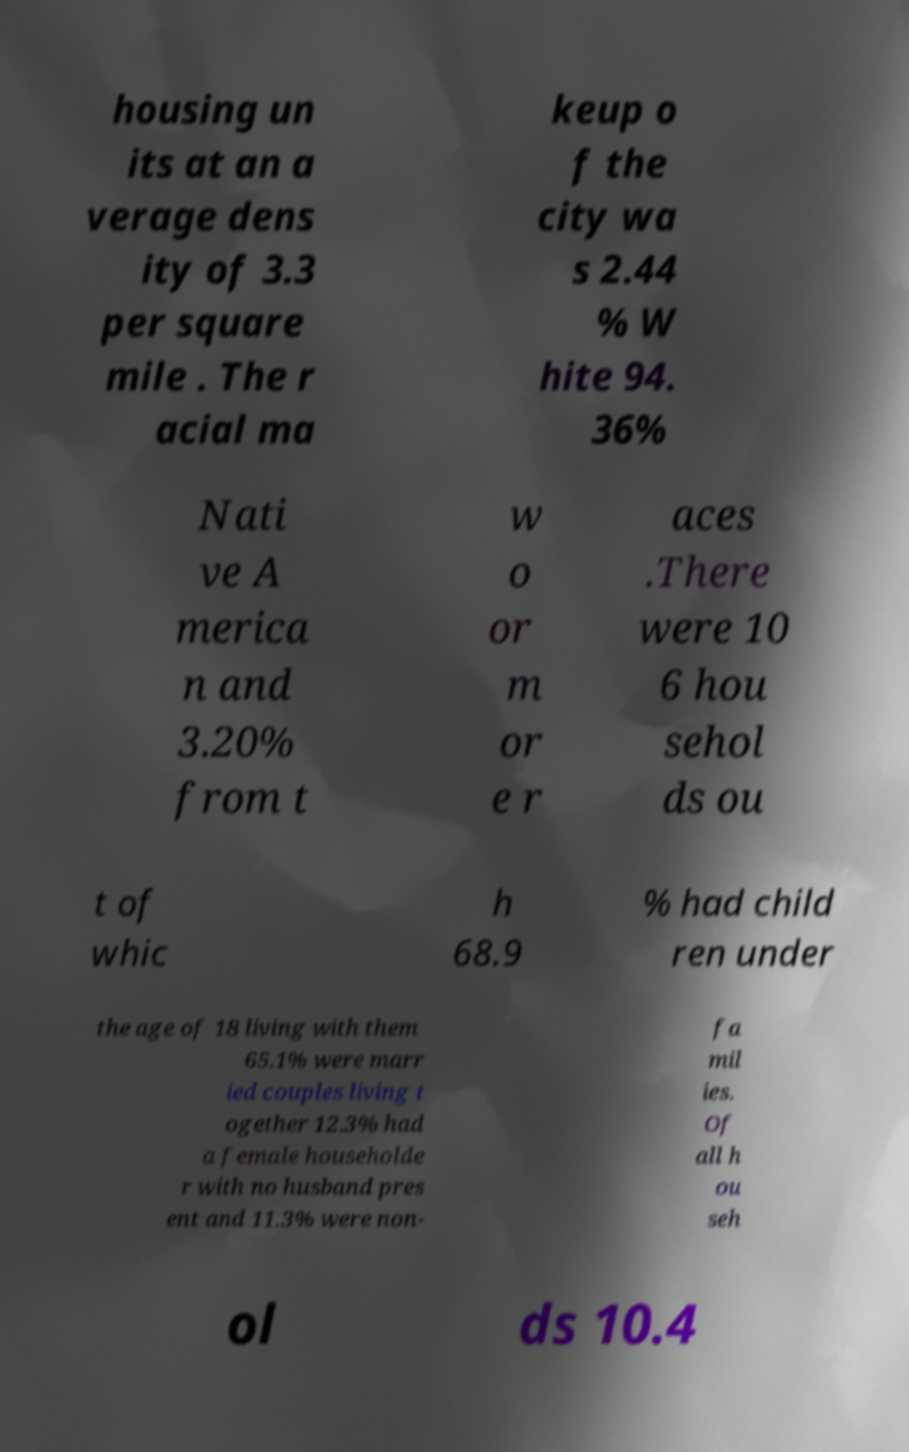Please identify and transcribe the text found in this image. housing un its at an a verage dens ity of 3.3 per square mile . The r acial ma keup o f the city wa s 2.44 % W hite 94. 36% Nati ve A merica n and 3.20% from t w o or m or e r aces .There were 10 6 hou sehol ds ou t of whic h 68.9 % had child ren under the age of 18 living with them 65.1% were marr ied couples living t ogether 12.3% had a female householde r with no husband pres ent and 11.3% were non- fa mil ies. Of all h ou seh ol ds 10.4 